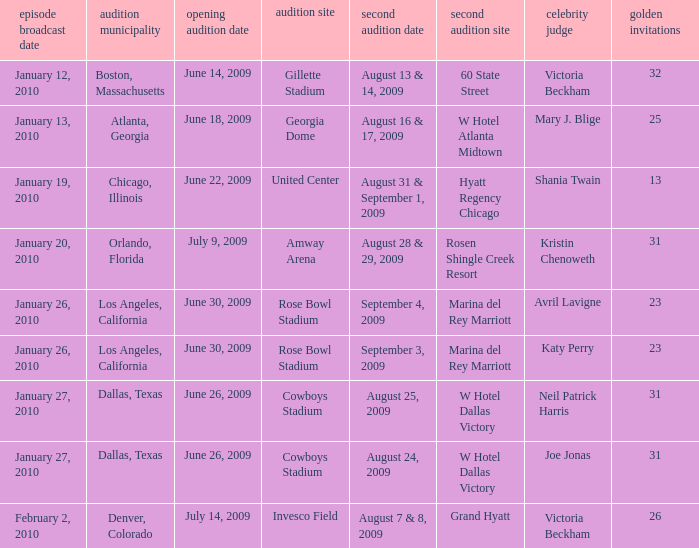Name the golden ticket for invesco field 26.0. 